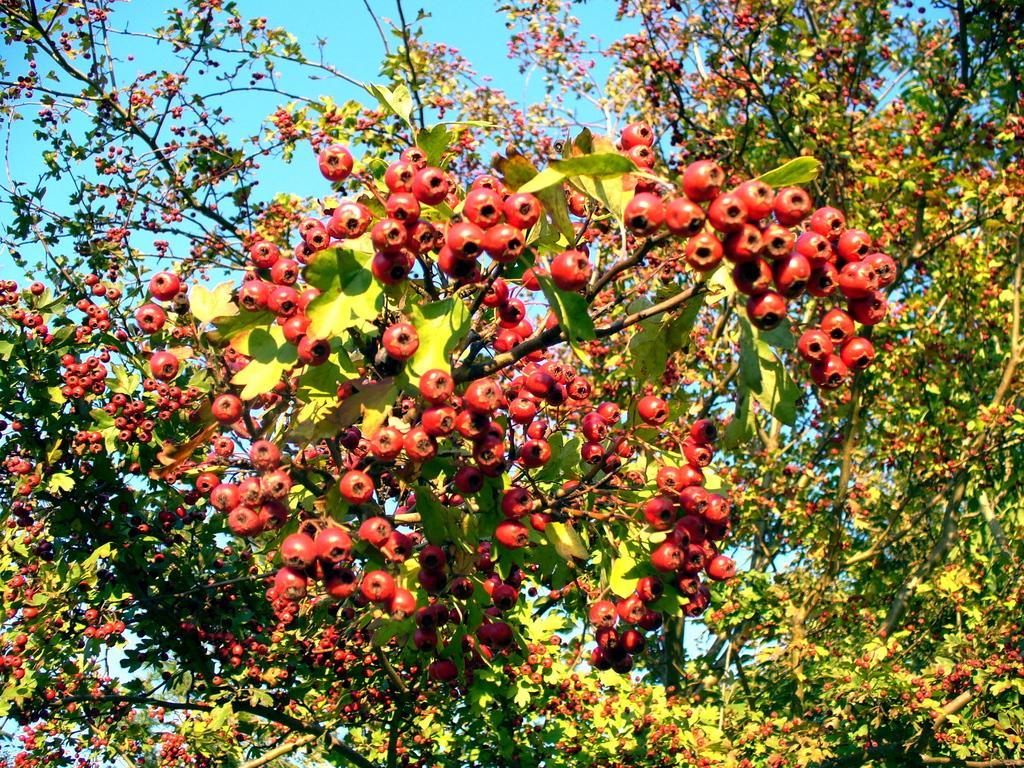What is present in the tree that can be seen in the image? There are fruits in the tree in the image. What part of the natural environment is visible in the image? The sky is visible in the image. What type of cracker is being used to hold the tree in the image? There is no cracker present in the image, and the tree is not being held by any object. 